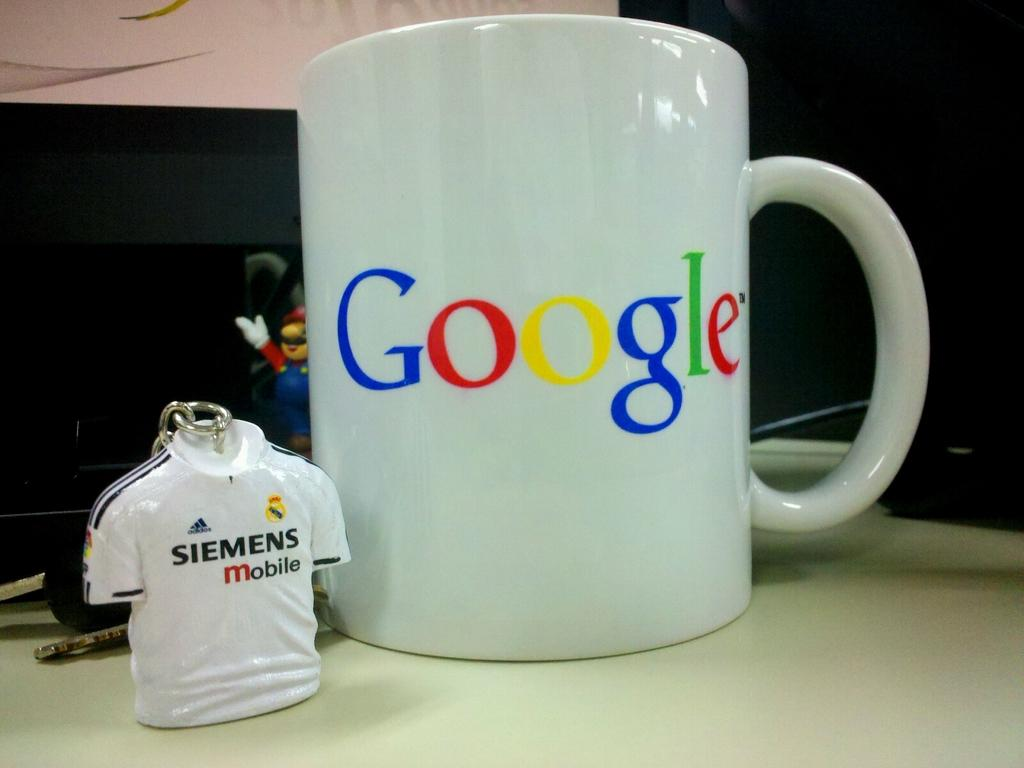<image>
Describe the image concisely. A Siemens jersey key chain sits next to a Google coffee mug. 